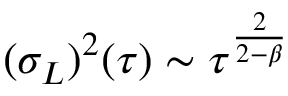<formula> <loc_0><loc_0><loc_500><loc_500>( \sigma _ { L } ) ^ { 2 } ( \tau ) \sim \tau ^ { \frac { 2 } { 2 - \beta } }</formula> 